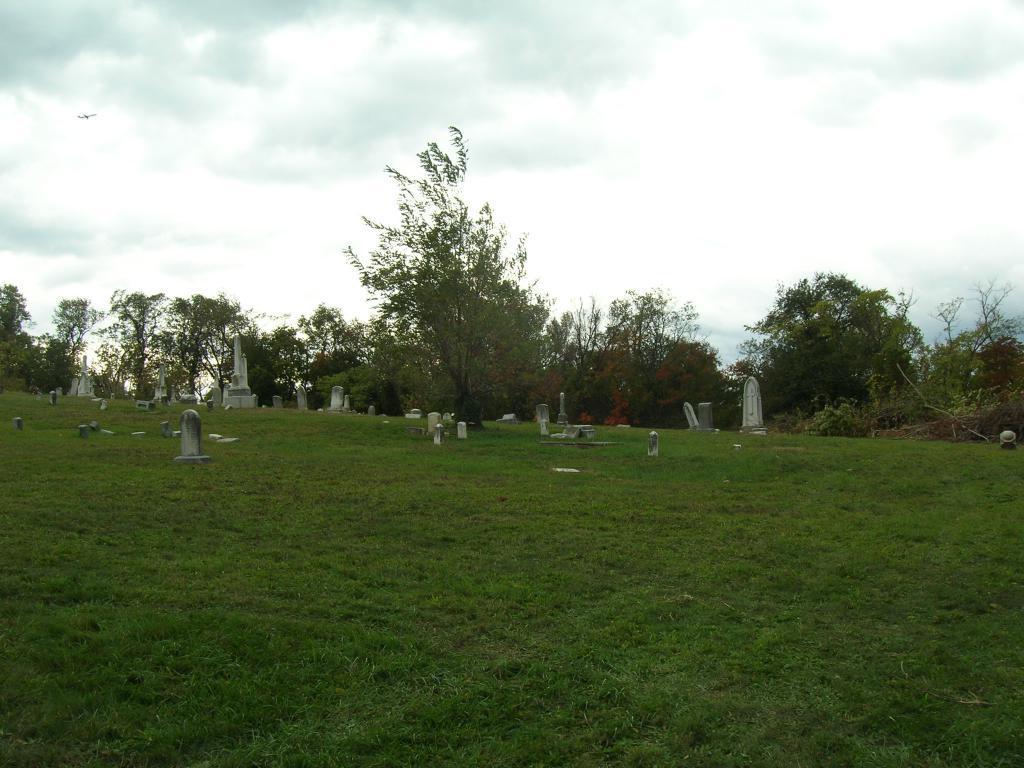How would you summarize this image in a sentence or two? In this image we can see graveyard. At the bottom of the image we can see grass. In the background we can see trees, sky and clouds. 